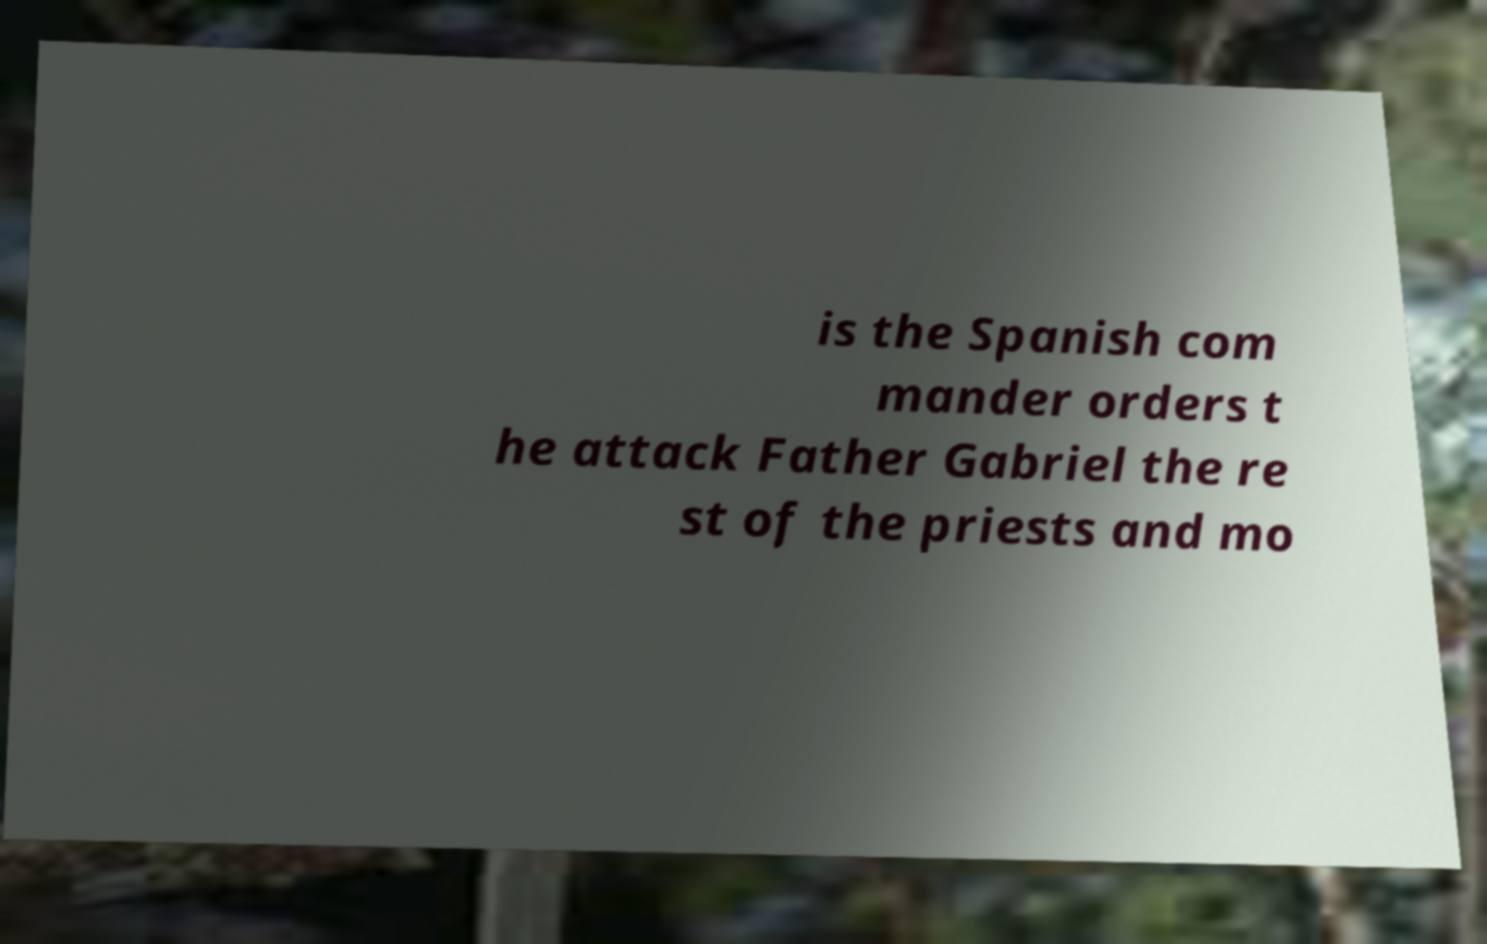Can you accurately transcribe the text from the provided image for me? is the Spanish com mander orders t he attack Father Gabriel the re st of the priests and mo 